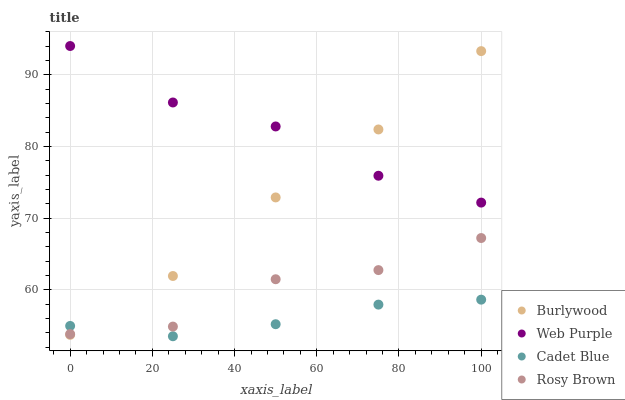Does Cadet Blue have the minimum area under the curve?
Answer yes or no. Yes. Does Web Purple have the maximum area under the curve?
Answer yes or no. Yes. Does Web Purple have the minimum area under the curve?
Answer yes or no. No. Does Cadet Blue have the maximum area under the curve?
Answer yes or no. No. Is Burlywood the smoothest?
Answer yes or no. Yes. Is Rosy Brown the roughest?
Answer yes or no. Yes. Is Web Purple the smoothest?
Answer yes or no. No. Is Web Purple the roughest?
Answer yes or no. No. Does Cadet Blue have the lowest value?
Answer yes or no. Yes. Does Web Purple have the lowest value?
Answer yes or no. No. Does Web Purple have the highest value?
Answer yes or no. Yes. Does Cadet Blue have the highest value?
Answer yes or no. No. Is Cadet Blue less than Web Purple?
Answer yes or no. Yes. Is Web Purple greater than Rosy Brown?
Answer yes or no. Yes. Does Rosy Brown intersect Burlywood?
Answer yes or no. Yes. Is Rosy Brown less than Burlywood?
Answer yes or no. No. Is Rosy Brown greater than Burlywood?
Answer yes or no. No. Does Cadet Blue intersect Web Purple?
Answer yes or no. No. 